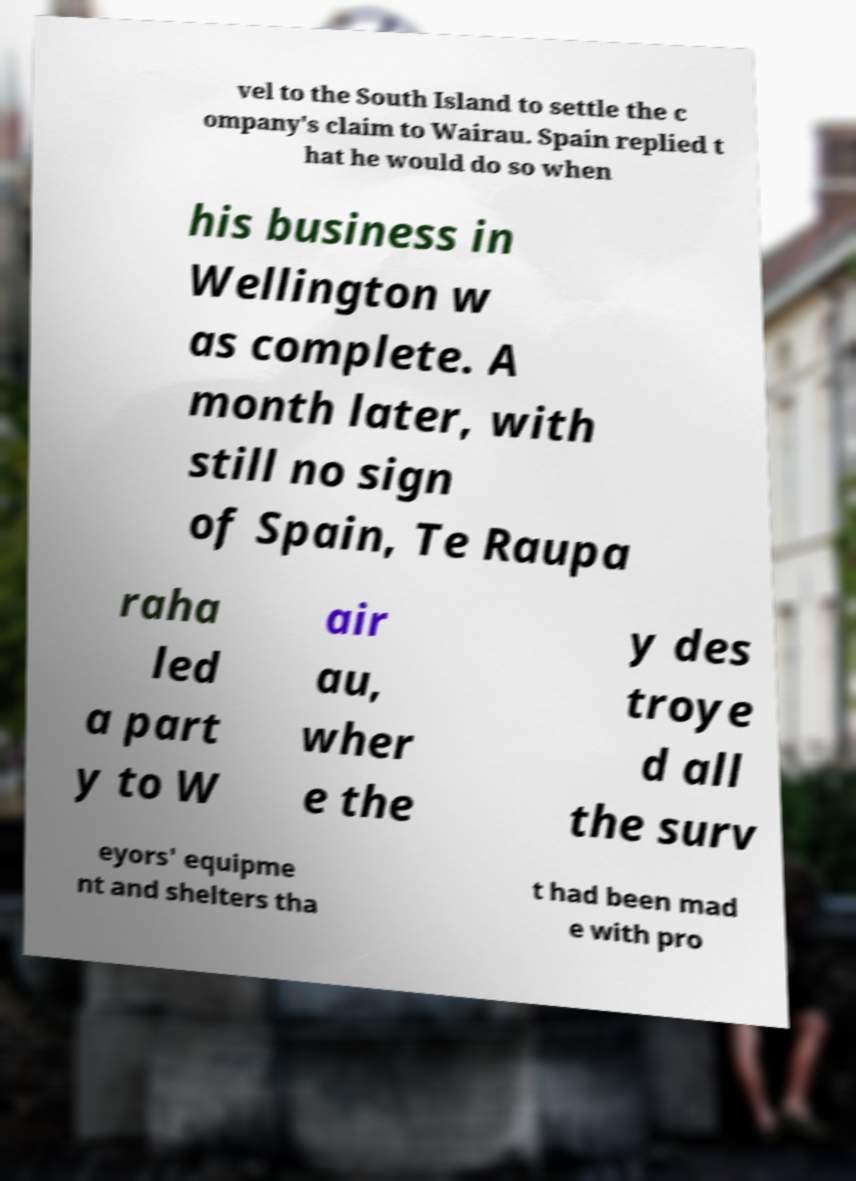Please read and relay the text visible in this image. What does it say? vel to the South Island to settle the c ompany's claim to Wairau. Spain replied t hat he would do so when his business in Wellington w as complete. A month later, with still no sign of Spain, Te Raupa raha led a part y to W air au, wher e the y des troye d all the surv eyors' equipme nt and shelters tha t had been mad e with pro 